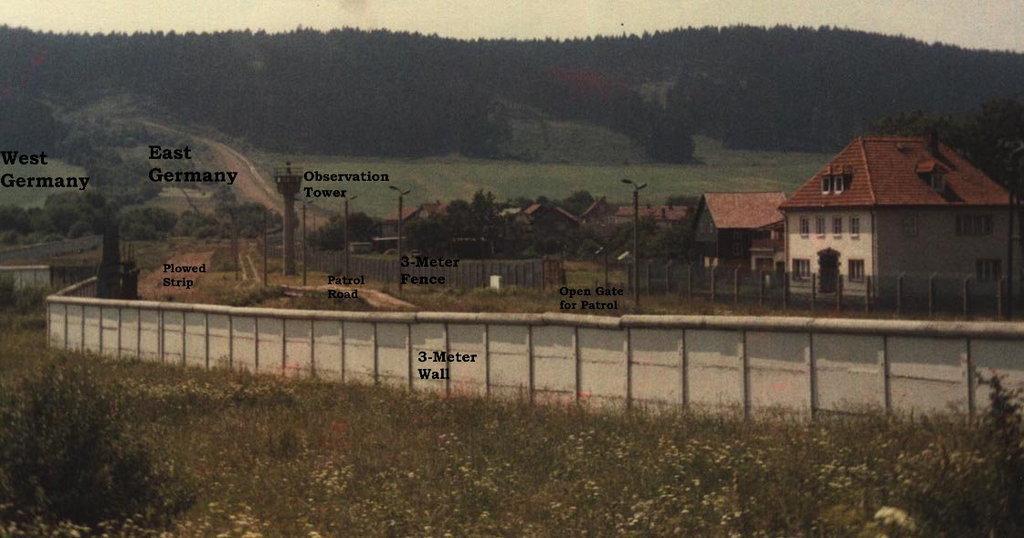Please provide a concise description of this image. This is an edited image. In this image there are buildings, in front of the buildings there are street lights, trees, plants, grass, fencing wall, path and in the background there is the sky. 